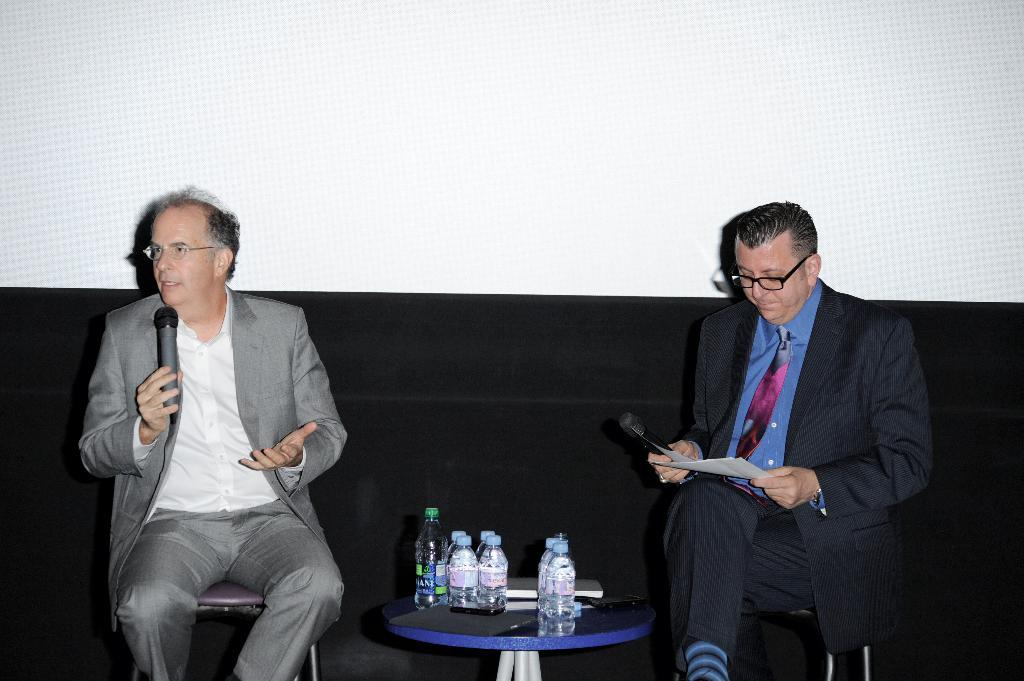How many people are sitting in the image? There are two people sitting in the image. What can be seen besides the people in the image? There are bottles and other objects visible in the image. What is the color scheme of the background in the image? The background of the image is in black and white color. What year is depicted in the image? The provided facts do not mention any specific year or time period, so it is not possible to determine the year from the image. 